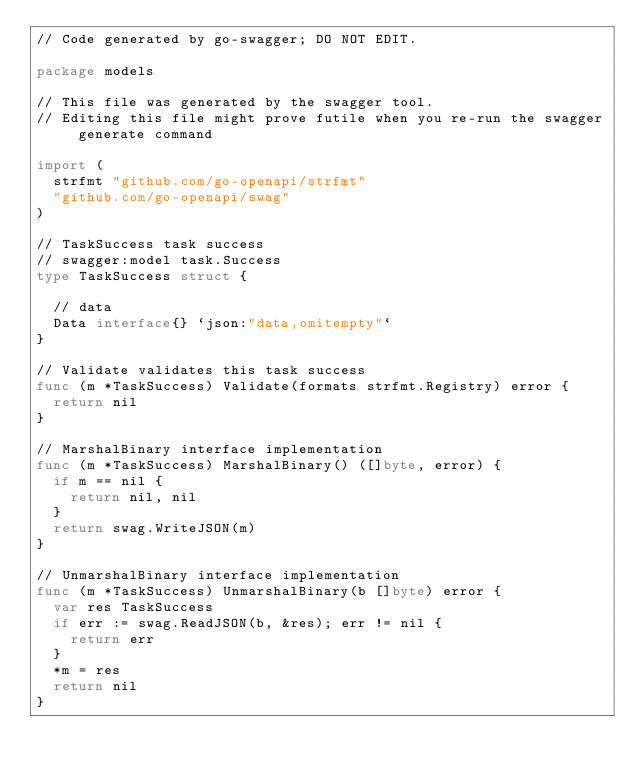Convert code to text. <code><loc_0><loc_0><loc_500><loc_500><_Go_>// Code generated by go-swagger; DO NOT EDIT.

package models

// This file was generated by the swagger tool.
// Editing this file might prove futile when you re-run the swagger generate command

import (
	strfmt "github.com/go-openapi/strfmt"
	"github.com/go-openapi/swag"
)

// TaskSuccess task success
// swagger:model task.Success
type TaskSuccess struct {

	// data
	Data interface{} `json:"data,omitempty"`
}

// Validate validates this task success
func (m *TaskSuccess) Validate(formats strfmt.Registry) error {
	return nil
}

// MarshalBinary interface implementation
func (m *TaskSuccess) MarshalBinary() ([]byte, error) {
	if m == nil {
		return nil, nil
	}
	return swag.WriteJSON(m)
}

// UnmarshalBinary interface implementation
func (m *TaskSuccess) UnmarshalBinary(b []byte) error {
	var res TaskSuccess
	if err := swag.ReadJSON(b, &res); err != nil {
		return err
	}
	*m = res
	return nil
}
</code> 